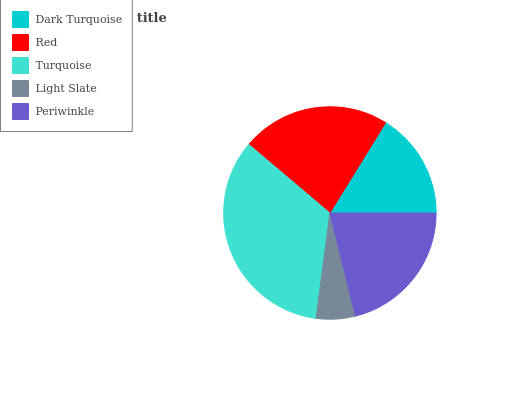Is Light Slate the minimum?
Answer yes or no. Yes. Is Turquoise the maximum?
Answer yes or no. Yes. Is Red the minimum?
Answer yes or no. No. Is Red the maximum?
Answer yes or no. No. Is Red greater than Dark Turquoise?
Answer yes or no. Yes. Is Dark Turquoise less than Red?
Answer yes or no. Yes. Is Dark Turquoise greater than Red?
Answer yes or no. No. Is Red less than Dark Turquoise?
Answer yes or no. No. Is Periwinkle the high median?
Answer yes or no. Yes. Is Periwinkle the low median?
Answer yes or no. Yes. Is Red the high median?
Answer yes or no. No. Is Red the low median?
Answer yes or no. No. 